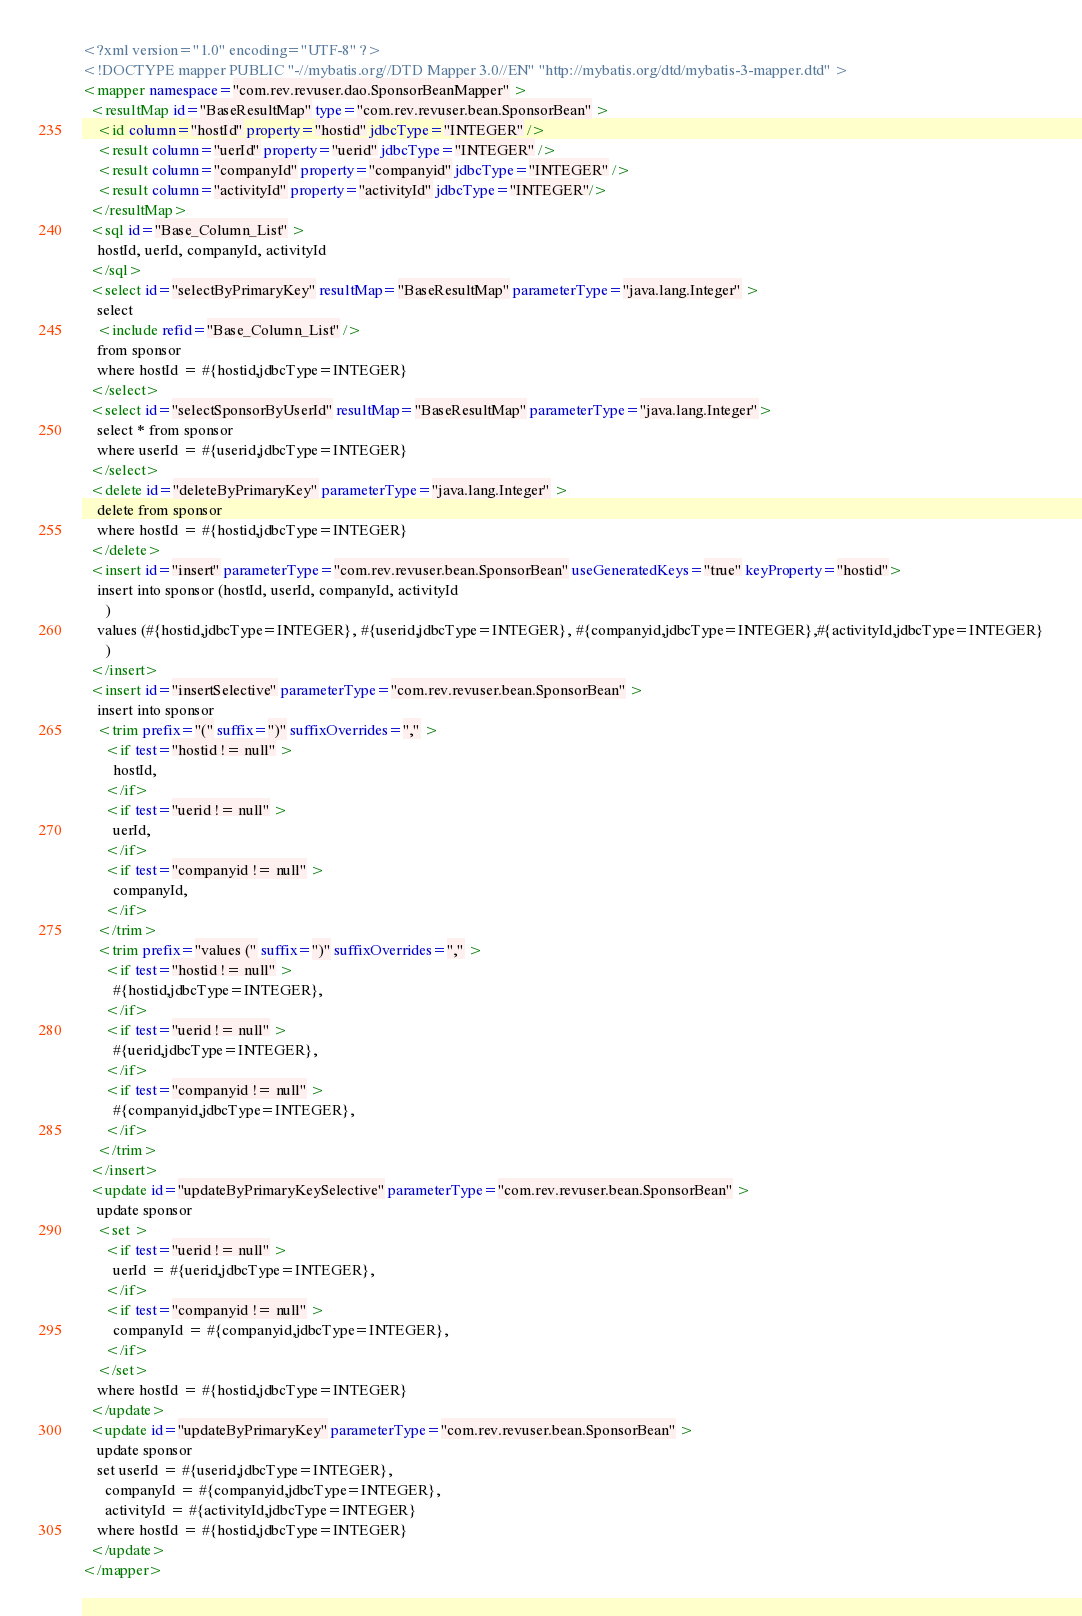<code> <loc_0><loc_0><loc_500><loc_500><_XML_><?xml version="1.0" encoding="UTF-8" ?>
<!DOCTYPE mapper PUBLIC "-//mybatis.org//DTD Mapper 3.0//EN" "http://mybatis.org/dtd/mybatis-3-mapper.dtd" >
<mapper namespace="com.rev.revuser.dao.SponsorBeanMapper" >
  <resultMap id="BaseResultMap" type="com.rev.revuser.bean.SponsorBean" >
    <id column="hostId" property="hostid" jdbcType="INTEGER" />
    <result column="uerId" property="uerid" jdbcType="INTEGER" />
    <result column="companyId" property="companyid" jdbcType="INTEGER" />
    <result column="activityId" property="activityId" jdbcType="INTEGER"/>
  </resultMap>
  <sql id="Base_Column_List" >
    hostId, uerId, companyId, activityId
  </sql>
  <select id="selectByPrimaryKey" resultMap="BaseResultMap" parameterType="java.lang.Integer" >
    select 
    <include refid="Base_Column_List" />
    from sponsor
    where hostId = #{hostid,jdbcType=INTEGER}
  </select>
  <select id="selectSponsorByUserId" resultMap="BaseResultMap" parameterType="java.lang.Integer">
    select * from sponsor
    where userId = #{userid,jdbcType=INTEGER}
  </select>
  <delete id="deleteByPrimaryKey" parameterType="java.lang.Integer" >
    delete from sponsor
    where hostId = #{hostid,jdbcType=INTEGER}
  </delete>
  <insert id="insert" parameterType="com.rev.revuser.bean.SponsorBean" useGeneratedKeys="true" keyProperty="hostid">
    insert into sponsor (hostId, userId, companyId, activityId
      )
    values (#{hostid,jdbcType=INTEGER}, #{userid,jdbcType=INTEGER}, #{companyid,jdbcType=INTEGER},#{activityId,jdbcType=INTEGER}
      )
  </insert>
  <insert id="insertSelective" parameterType="com.rev.revuser.bean.SponsorBean" >
    insert into sponsor
    <trim prefix="(" suffix=")" suffixOverrides="," >
      <if test="hostid != null" >
        hostId,
      </if>
      <if test="uerid != null" >
        uerId,
      </if>
      <if test="companyid != null" >
        companyId,
      </if>
    </trim>
    <trim prefix="values (" suffix=")" suffixOverrides="," >
      <if test="hostid != null" >
        #{hostid,jdbcType=INTEGER},
      </if>
      <if test="uerid != null" >
        #{uerid,jdbcType=INTEGER},
      </if>
      <if test="companyid != null" >
        #{companyid,jdbcType=INTEGER},
      </if>
    </trim>
  </insert>
  <update id="updateByPrimaryKeySelective" parameterType="com.rev.revuser.bean.SponsorBean" >
    update sponsor
    <set >
      <if test="uerid != null" >
        uerId = #{uerid,jdbcType=INTEGER},
      </if>
      <if test="companyid != null" >
        companyId = #{companyid,jdbcType=INTEGER},
      </if>
    </set>
    where hostId = #{hostid,jdbcType=INTEGER}
  </update>
  <update id="updateByPrimaryKey" parameterType="com.rev.revuser.bean.SponsorBean" >
    update sponsor
    set userId = #{userid,jdbcType=INTEGER},
      companyId = #{companyid,jdbcType=INTEGER},
      activityId = #{activityId,jdbcType=INTEGER}
    where hostId = #{hostid,jdbcType=INTEGER}
  </update>
</mapper></code> 